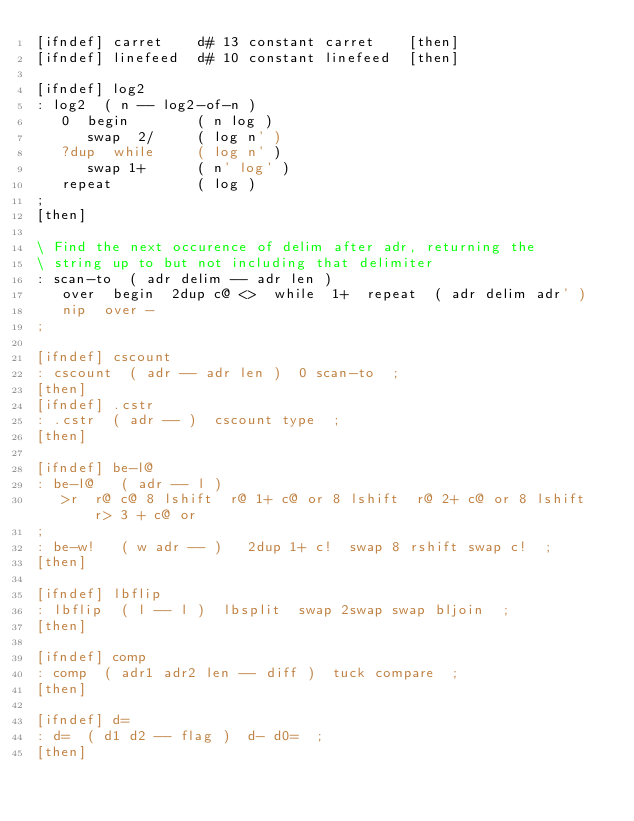Convert code to text. <code><loc_0><loc_0><loc_500><loc_500><_Forth_>[ifndef] carret    d# 13 constant carret    [then]
[ifndef] linefeed  d# 10 constant linefeed  [then]

[ifndef] log2
: log2  ( n -- log2-of-n )
   0  begin        ( n log )
      swap  2/     ( log n' )
   ?dup  while     ( log n' )
      swap 1+      ( n' log' )
   repeat          ( log )
;
[then]

\ Find the next occurence of delim after adr, returning the
\ string up to but not including that delimiter
: scan-to  ( adr delim -- adr len )
   over  begin  2dup c@ <>  while  1+  repeat  ( adr delim adr' )
   nip  over -
;

[ifndef] cscount
: cscount  ( adr -- adr len )  0 scan-to  ;
[then]
[ifndef] .cstr
: .cstr  ( adr -- )  cscount type  ;
[then]

[ifndef] be-l@
: be-l@   ( adr -- l )
   >r  r@ c@ 8 lshift  r@ 1+ c@ or 8 lshift  r@ 2+ c@ or 8 lshift  r> 3 + c@ or
;
: be-w!   ( w adr -- )   2dup 1+ c!  swap 8 rshift swap c!  ;
[then]

[ifndef] lbflip
: lbflip  ( l -- l )  lbsplit  swap 2swap swap bljoin  ;
[then]

[ifndef] comp
: comp  ( adr1 adr2 len -- diff )  tuck compare  ;
[then]

[ifndef] d=
: d=  ( d1 d2 -- flag )  d- d0=  ;
[then]
</code> 